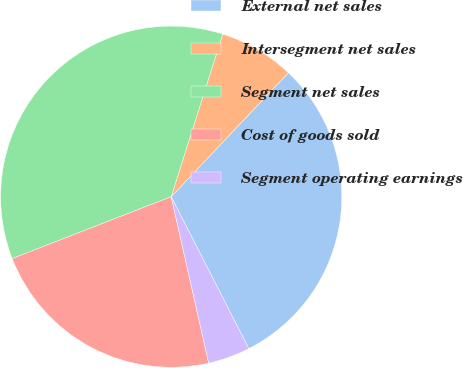Convert chart to OTSL. <chart><loc_0><loc_0><loc_500><loc_500><pie_chart><fcel>External net sales<fcel>Intersegment net sales<fcel>Segment net sales<fcel>Cost of goods sold<fcel>Segment operating earnings<nl><fcel>30.43%<fcel>7.17%<fcel>35.79%<fcel>22.62%<fcel>3.99%<nl></chart> 